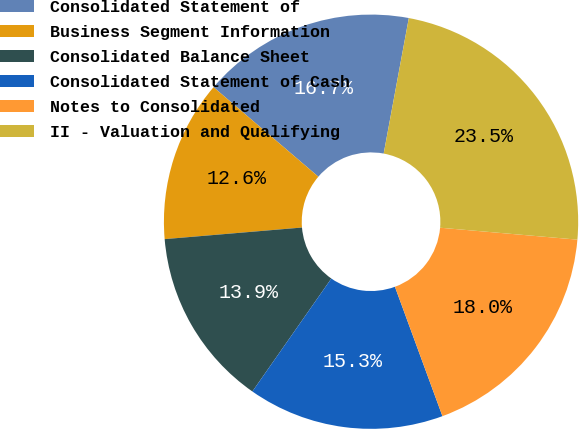Convert chart to OTSL. <chart><loc_0><loc_0><loc_500><loc_500><pie_chart><fcel>Consolidated Statement of<fcel>Business Segment Information<fcel>Consolidated Balance Sheet<fcel>Consolidated Statement of Cash<fcel>Notes to Consolidated<fcel>II - Valuation and Qualifying<nl><fcel>16.67%<fcel>12.59%<fcel>13.95%<fcel>15.31%<fcel>18.02%<fcel>23.46%<nl></chart> 